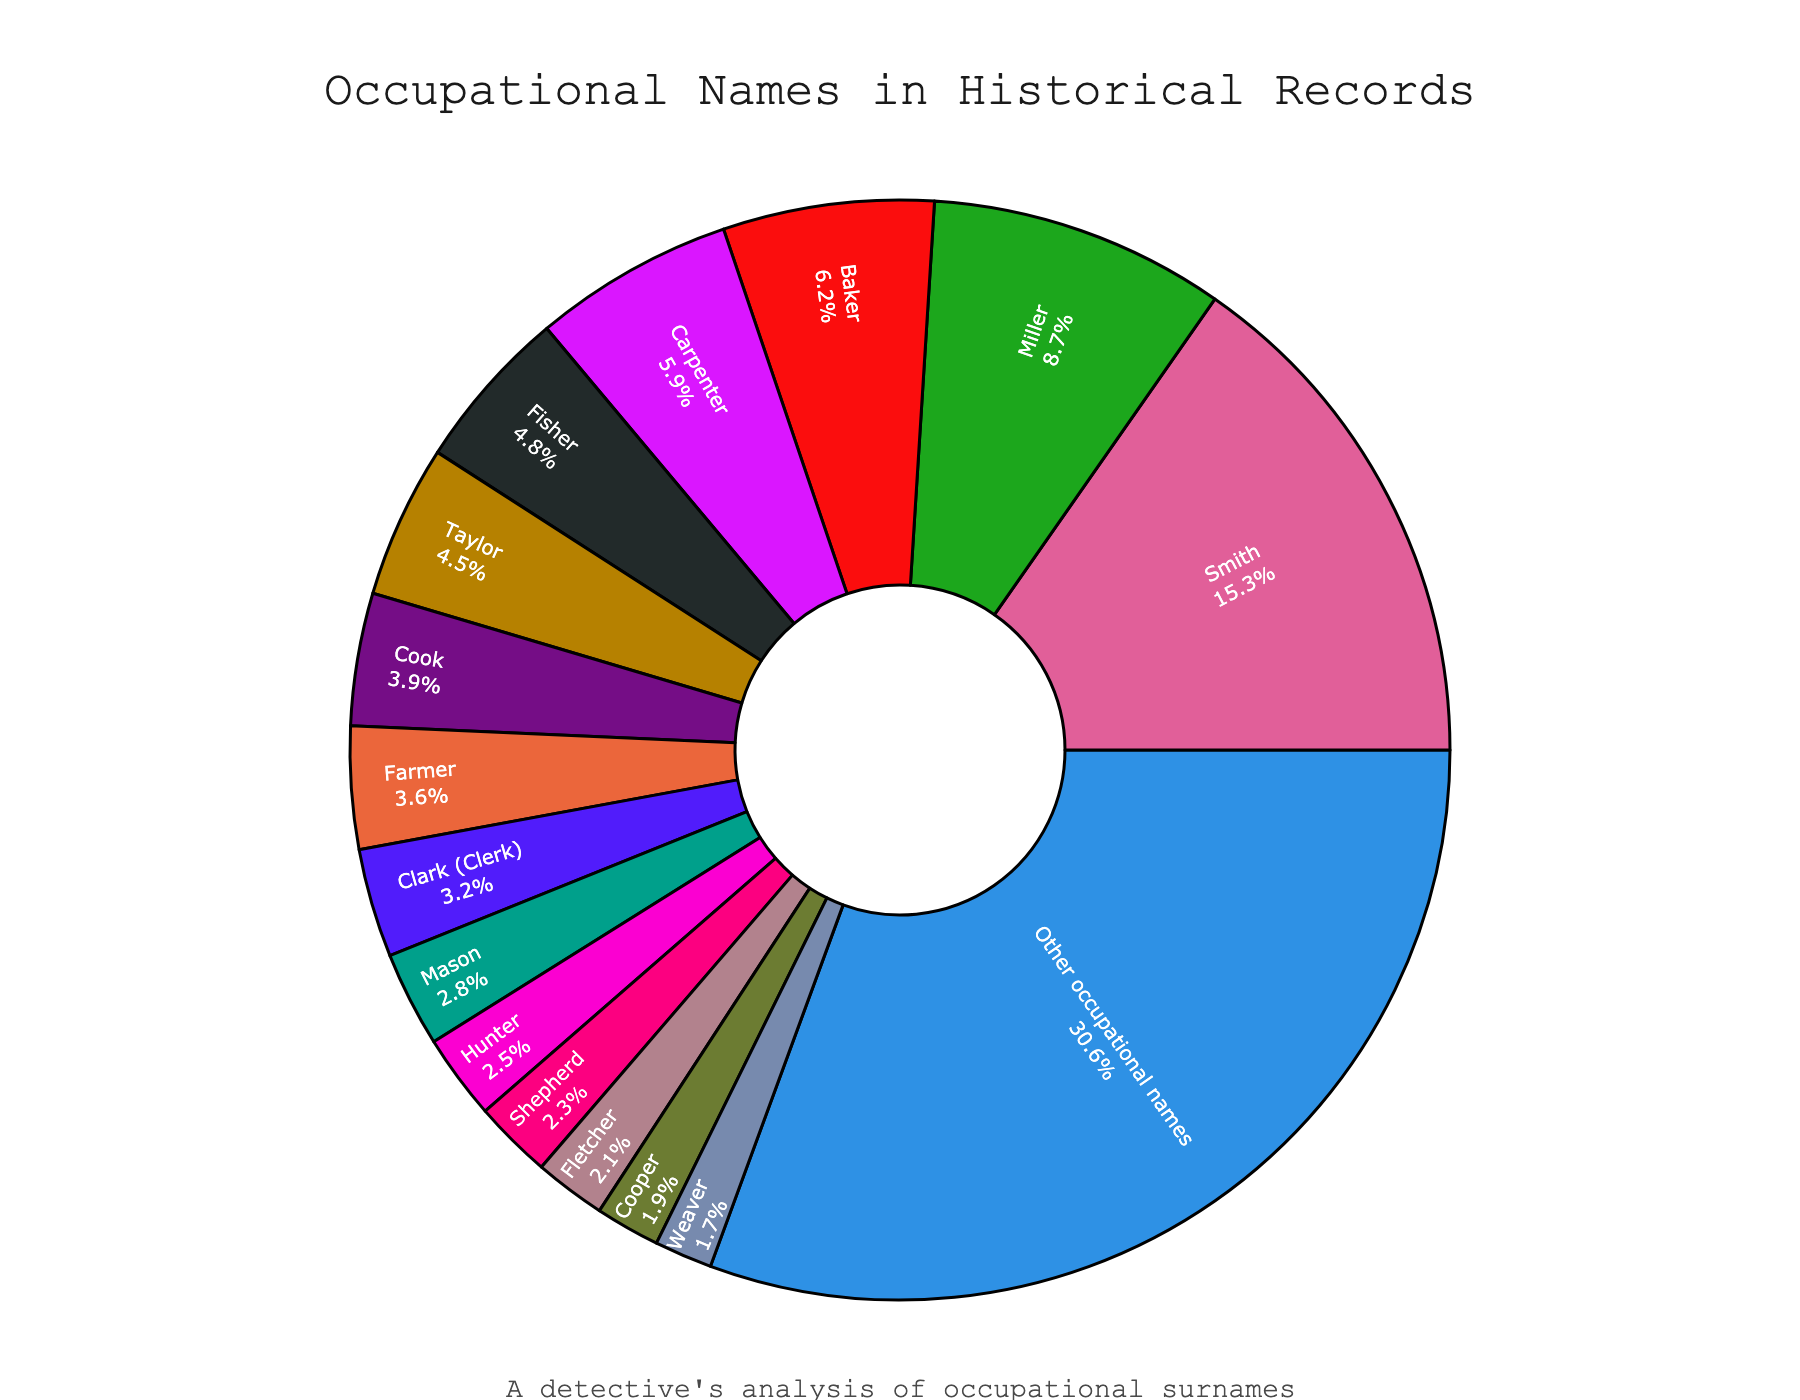What name origin has the highest percentage? The pie chart shows that "Smith" has the largest segment in terms of percentage. By checking the labels and their corresponding percentages, "Smith" is listed at 15.3%, which is the highest.
Answer: Smith Which two name origins together constitute more than 20%? Evaluating the percentages, "Smith" (15.3%) and "Miller" (8.7%) together add up to 24%. This is more than 20%.
Answer: Smith and Miller Is "Baker" more prevalent than "Cook"? Comparing the slices for "Baker" and "Cook," the pie chart shows that Baker has a percentage of 6.2%, whereas Cook has 3.9%. Since 6.2% is greater than 3.9%, "Baker" is more prevalent.
Answer: Yes How much larger is the percentage of "Smith" compared to "Carpenter"? "Smith" accounts for 15.3% while "Carpenter" accounts for 5.9%. The difference is calculated as 15.3% - 5.9% = 9.4%. Thus, "Smith" is 9.4% larger compared to "Carpenter."
Answer: 9.4% What is the combined percentage of names derived from "Fisher" and "Weaver"? "Fisher" has a percentage of 4.8% and "Weaver" has 1.7%. Adding these together gives: 4.8% + 1.7% = 6.5%.
Answer: 6.5% How many name origins are listed before the first origin with a percentage less than 4%? Scanning through the list in descending order of percentages, the threshold occurs at "Cook" with 3.9%. The preceding origins are "Smith," "Miller," "Baker," "Carpenter," "Fisher," and "Taylor." That's 6 name origins.
Answer: 6 Is the percentage for "Hunter" more than the combined percentage of "Fletcher" and "Cooper"? "Hunter" has a percentage of 2.5%, while "Fletcher" and "Cooper" together have 2.1% + 1.9% = 4.0%. Since 2.5% is less than 4.0%, "Hunter" is not more than the combined percentage of "Fletcher" and "Cooper."
Answer: No What is the approximate angle for the "Other occupational names" segment? The pie chart is circular, representing 360 degrees. "Other occupational names" is 30.6% of the chart. The angle is thus 30.6% of 360 degrees: 0.306 * 360 = 110.16 degrees.
Answer: 110.16 degrees Which segment is just under "Taylor" in percentage? The labels show "Taylor" at 4.5%. The next lower percentage is "Cook" with 3.9%. Hence, the segment just under "Taylor" is "Cook."
Answer: Cook Are there more name origins with percentages greater than 5% or less than 3%? Name origins with percentages greater than 5%: "Smith," "Miller," "Baker," "Carpenter," and "Fisher" (5 origins). For percentages less than 3%: "Mason," "Hunter," "Shepherd," "Fletcher," "Cooper," and "Weaver" (6 origins). There are more name origins with percentages less than 3%.
Answer: Less than 3% 